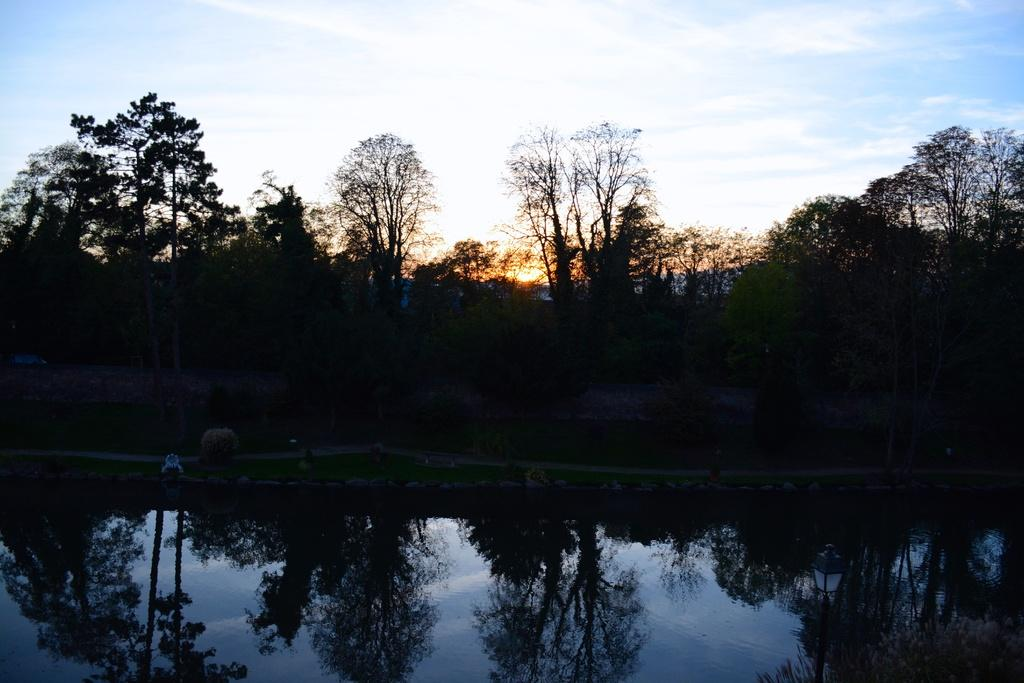What type of vegetation can be seen in the image? There are trees in the image. What else can be seen besides trees in the image? There is water and grass visible in the image. What is visible in the background of the image? The sky is visible in the background of the image. What can be observed in the sky? Clouds are present in the sky. What degree of brightness is emitted by the ground in the image? There is no mention of the ground in the image, and therefore no information about its brightness can be provided. 